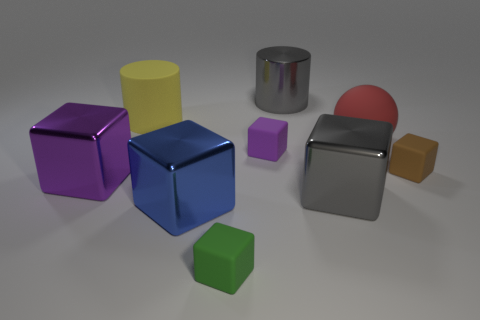Add 1 large gray rubber balls. How many objects exist? 10 Subtract all purple rubber blocks. How many blocks are left? 5 Subtract all cylinders. How many objects are left? 7 Subtract 1 cylinders. How many cylinders are left? 1 Subtract all gray blocks. How many blocks are left? 5 Subtract all cyan balls. Subtract all red blocks. How many balls are left? 1 Subtract all red cylinders. How many gray cubes are left? 1 Subtract all cubes. Subtract all rubber balls. How many objects are left? 2 Add 7 yellow rubber objects. How many yellow rubber objects are left? 8 Add 2 tiny gray metal balls. How many tiny gray metal balls exist? 2 